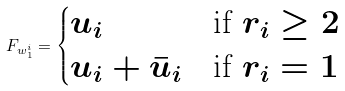<formula> <loc_0><loc_0><loc_500><loc_500>F _ { w _ { 1 } ^ { i } } = \begin{cases} u _ { i } & \text {if $r_{i}\geq 2$} \\ u _ { i } + \bar { u } _ { i } & \text {if $r_{i}=1$} \end{cases}</formula> 